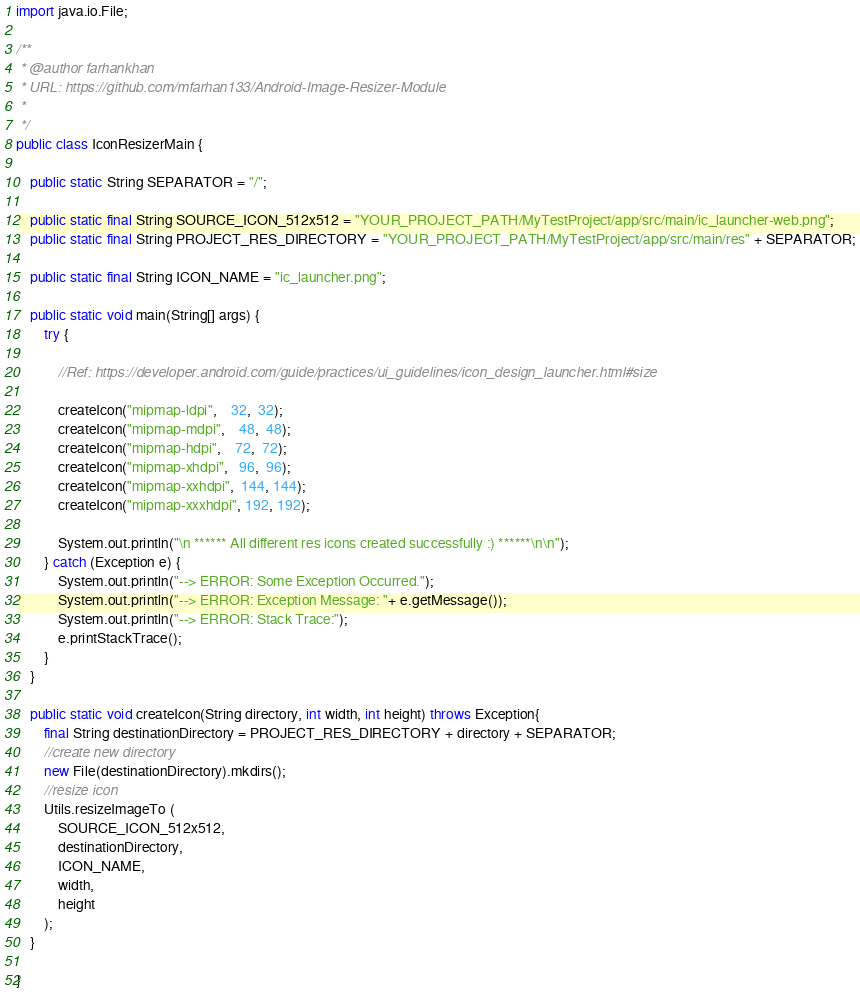<code> <loc_0><loc_0><loc_500><loc_500><_Java_>import java.io.File;

/**
 * @author farhankhan
 * URL: https://github.com/mfarhan133/Android-Image-Resizer-Module
 *
 */
public class IconResizerMain {

    public static String SEPARATOR = "/";

    public static final String SOURCE_ICON_512x512 = "YOUR_PROJECT_PATH/MyTestProject/app/src/main/ic_launcher-web.png";
    public static final String PROJECT_RES_DIRECTORY = "YOUR_PROJECT_PATH/MyTestProject/app/src/main/res" + SEPARATOR;

    public static final String ICON_NAME = "ic_launcher.png";

    public static void main(String[] args) {
        try {

            //Ref: https://developer.android.com/guide/practices/ui_guidelines/icon_design_launcher.html#size

            createIcon("mipmap-ldpi",    32,  32);
            createIcon("mipmap-mdpi",    48,  48);
            createIcon("mipmap-hdpi",    72,  72);
            createIcon("mipmap-xhdpi",   96,  96);
            createIcon("mipmap-xxhdpi",  144, 144);
            createIcon("mipmap-xxxhdpi", 192, 192);

            System.out.println("\n ****** All different res icons created successfully :) ******\n\n");
        } catch (Exception e) {
            System.out.println("--> ERROR: Some Exception Occurred.");
            System.out.println("--> ERROR: Exception Message: "+ e.getMessage());
            System.out.println("--> ERROR: Stack Trace:");
            e.printStackTrace();
        }
    }

    public static void createIcon(String directory, int width, int height) throws Exception{
        final String destinationDirectory = PROJECT_RES_DIRECTORY + directory + SEPARATOR;
        //create new directory
        new File(destinationDirectory).mkdirs();
        //resize icon
        Utils.resizeImageTo (
            SOURCE_ICON_512x512,
            destinationDirectory,
            ICON_NAME,
            width,
            height
        );
    }

}
</code> 